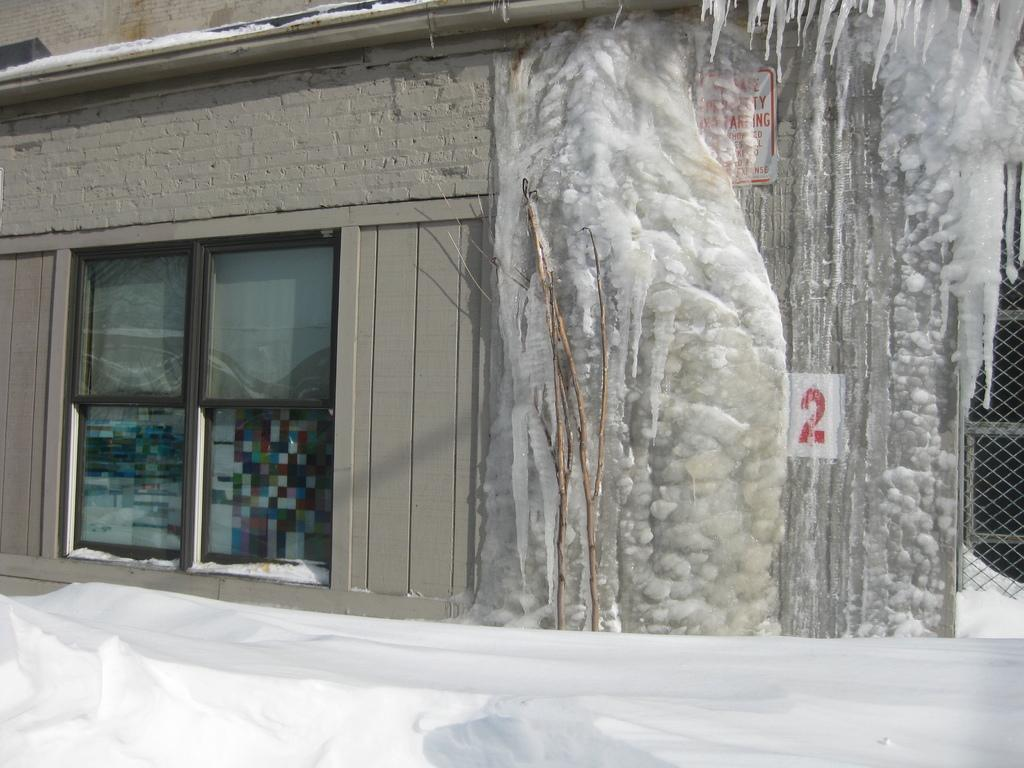What is the main feature in the image? There is a snow wall in the image. Where is the snow wall located in relation to the building? The snow wall is near a building. What type of windows does the building have? The building has glass windows. Is there any snow on the building? Yes, there is snow on the building. What is located near the snow wall? There is a fencing near the snow wall. What type of stone is used to build the hydrant in the image? There is no hydrant present in the image, so it is not possible to determine the type of stone used to build it. 